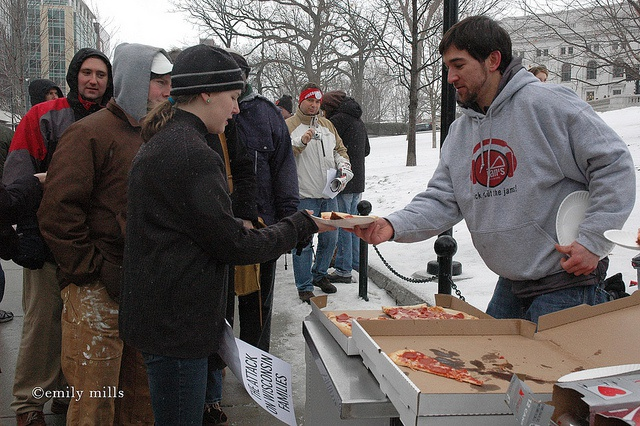Describe the objects in this image and their specific colors. I can see people in darkgray, gray, and black tones, people in darkgray, black, and gray tones, people in darkgray, black, maroon, and gray tones, people in darkgray, black, maroon, and gray tones, and people in darkgray, black, gray, and maroon tones in this image. 